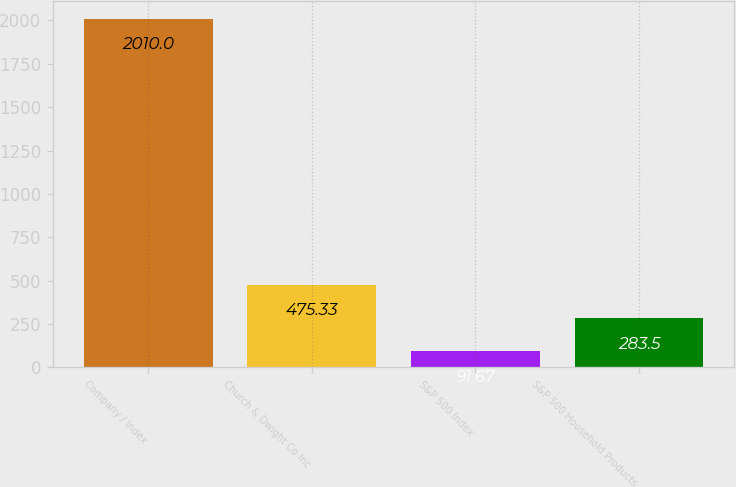<chart> <loc_0><loc_0><loc_500><loc_500><bar_chart><fcel>Company / Index<fcel>Church & Dwight Co Inc<fcel>S&P 500 Index<fcel>S&P 500 Household Products<nl><fcel>2010<fcel>475.33<fcel>91.67<fcel>283.5<nl></chart> 